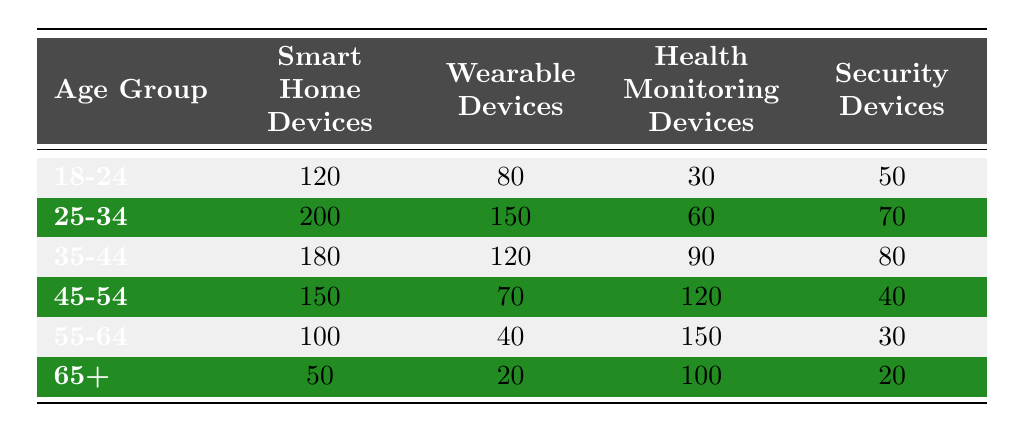What is the number of Smart Home Devices owned by the 25-34 age group? The table shows that the number of Smart Home Devices for the 25-34 age group is listed directly in the table under the corresponding column. It states there are 200 Smart Home Devices for this age group.
Answer: 200 Which age group has the highest number of Wearable Devices? By comparing the Wearable Devices column across all age groups, the greatest value is for the 25-34 age group with 150 devices, which is higher than any other group's count.
Answer: 25-34 What is the total number of Health Monitoring Devices owned by all age groups combined? To find the total, add up the Health Monitoring Devices for all age groups: 30 + 60 + 90 + 120 + 150 + 100 = 550.
Answer: 550 True or False: The 45-54 age group has more Security Devices than the 18-24 age group. By comparing the Security Devices of both age groups from the table, the 45-54 age group has 40 devices while the 18-24 group has 50. Therefore, 40 is less than 50.
Answer: False How many more Smart Home Devices does the 35-44 age group have compared to the 65+ age group? Subtract the number of Smart Home Devices in the 65+ age group from those in the 35-44 age group: 180 (35-44 group) - 50 (65+ group) = 130.
Answer: 130 Which age group has the lowest number of Security Devices, and how many do they have? The table indicates that the 65+ age group has the fewest Security Devices at 20, which can be confirmed by comparing all age groups.
Answer: 65+; 20 What is the average number of Wearable Devices across all age groups? To find the average, sum the number of Wearable Devices for each age group: 80 + 150 + 120 + 70 + 40 + 20 = 480. Divide by the number of age groups (6): 480 / 6 = 80.
Answer: 80 True or False: The total number of Smart Home Devices owned by the 55-64 age group is greater than that of the 45-54 age group. Comparing the two groups, the 55-64 age group has 100 Smart Home Devices, while the 45-54 group has 150. Hence, 100 is less than 150.
Answer: False 